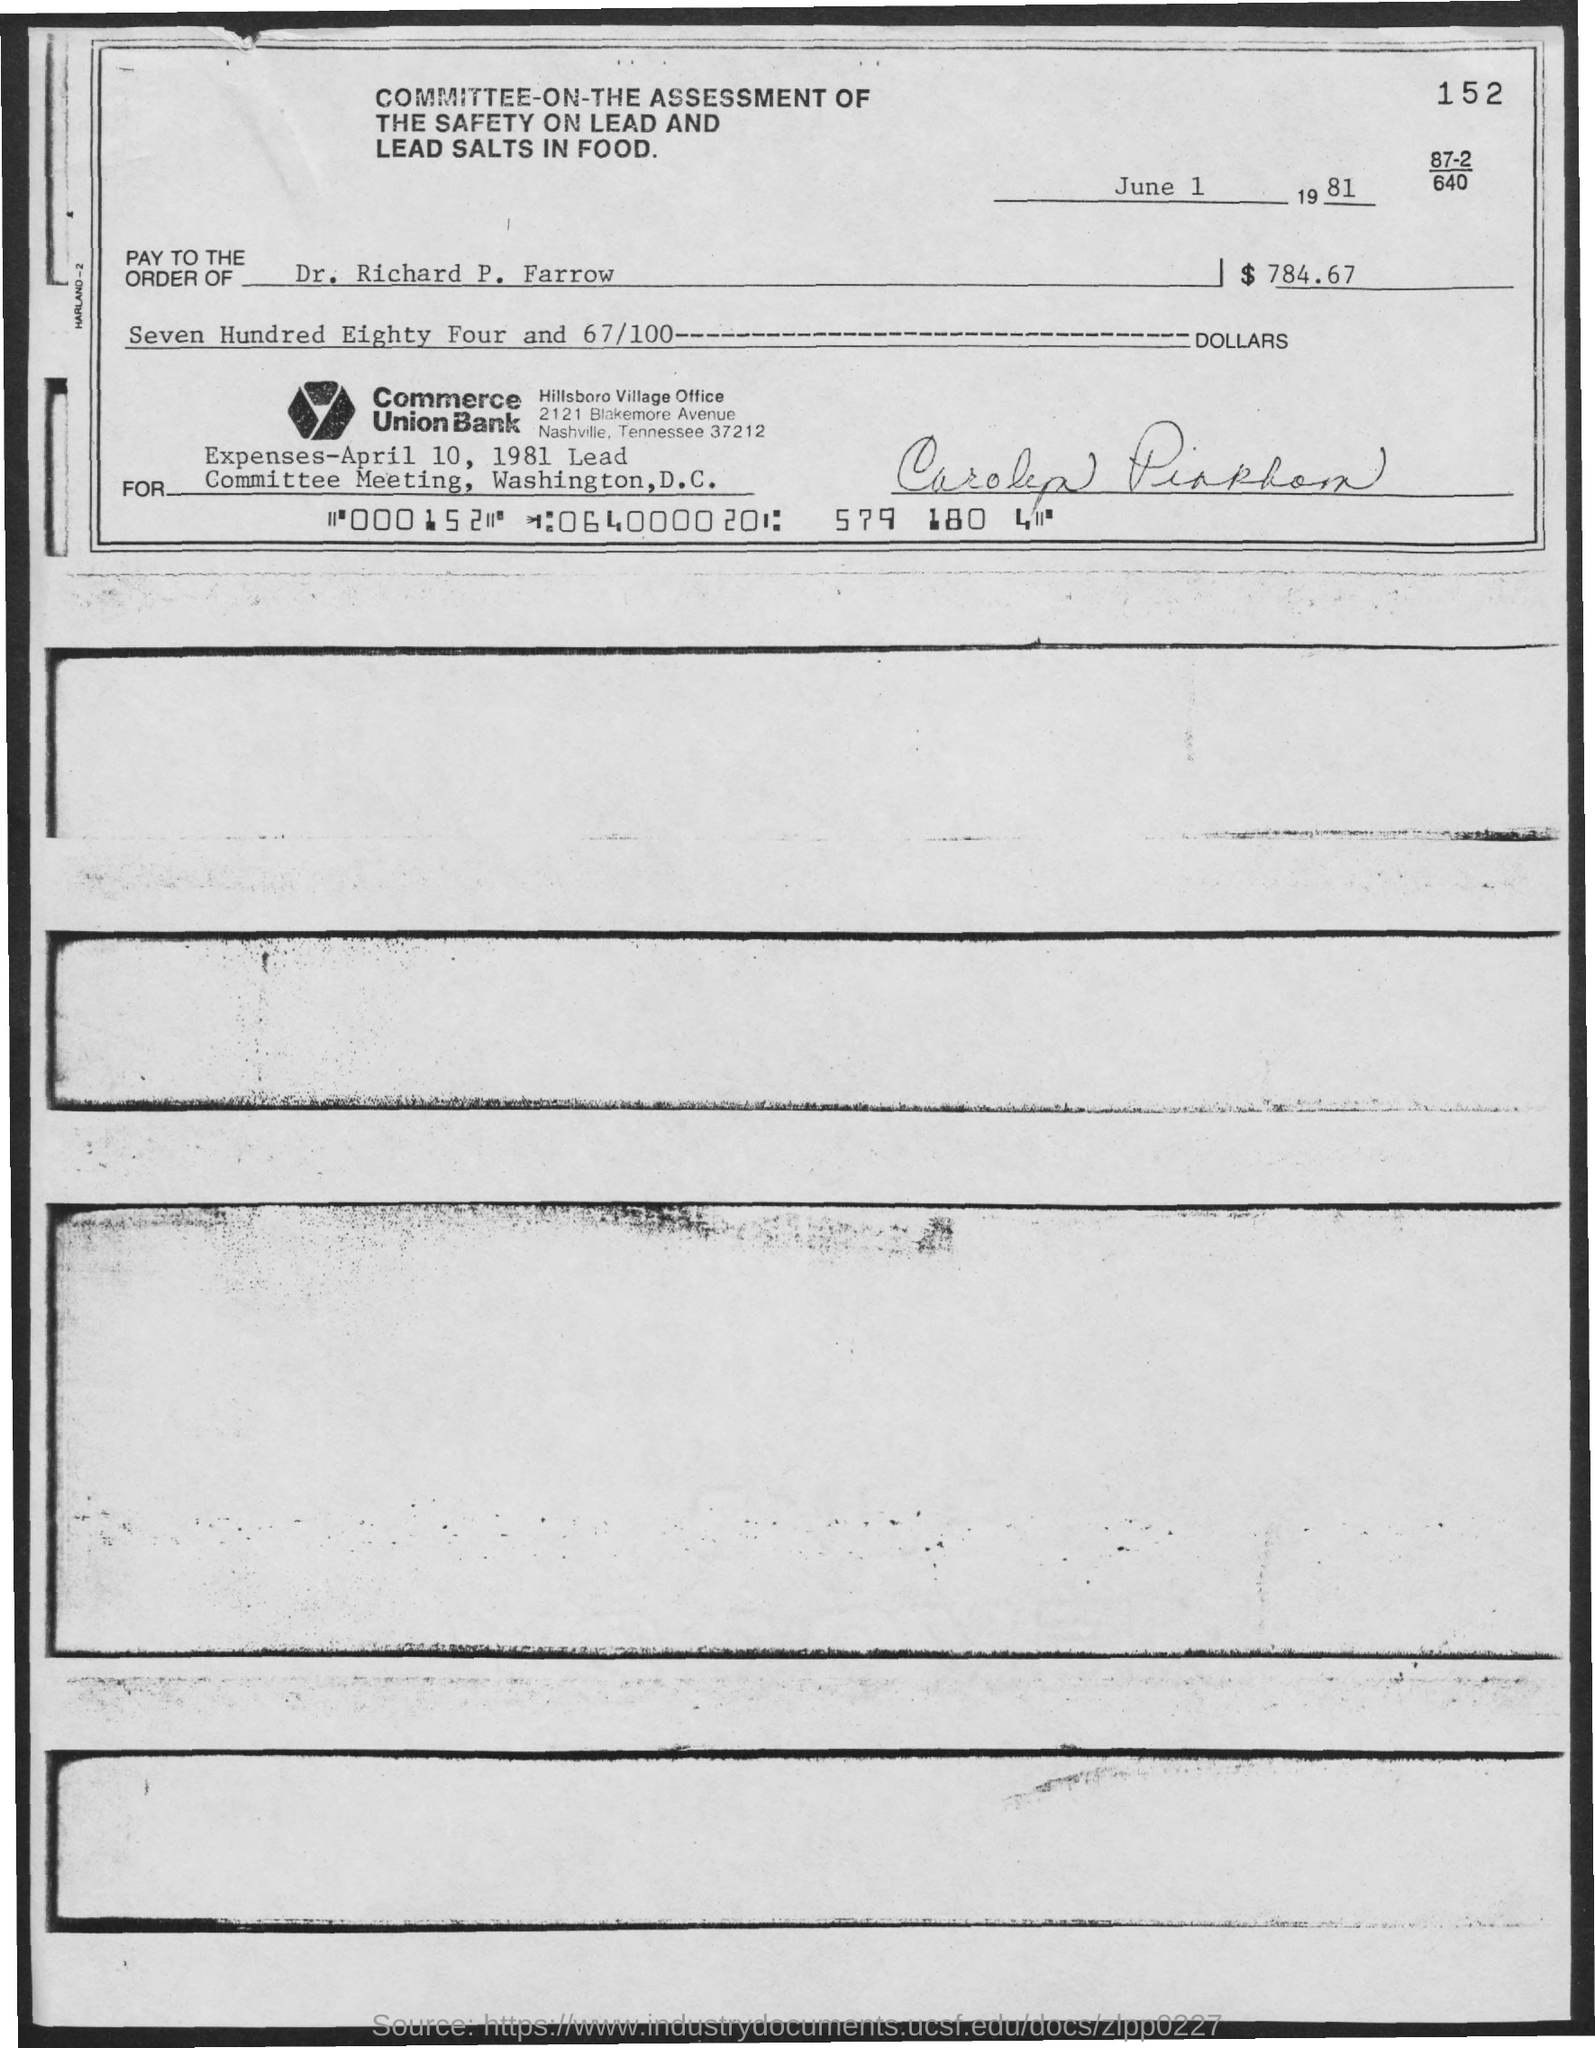Point out several critical features in this image. The date mentioned at the top of the document is June 1, 1981. What is the number written at the top right corner of this document? It appears to be 152. The committee is called the Committee on the Assessment of the Safety of Lead and Lead Salts in Food. 